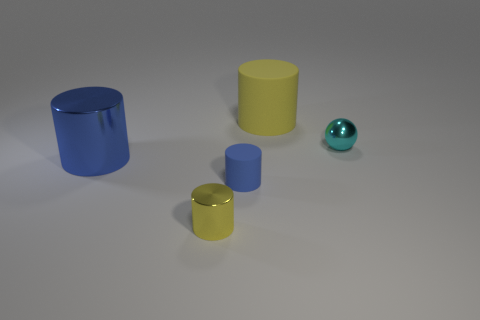What number of green blocks are there? There are no green blocks in the image. Instead, there is a variety of other colored objects including blue and yellow cylinders, as well as a teal sphere. 